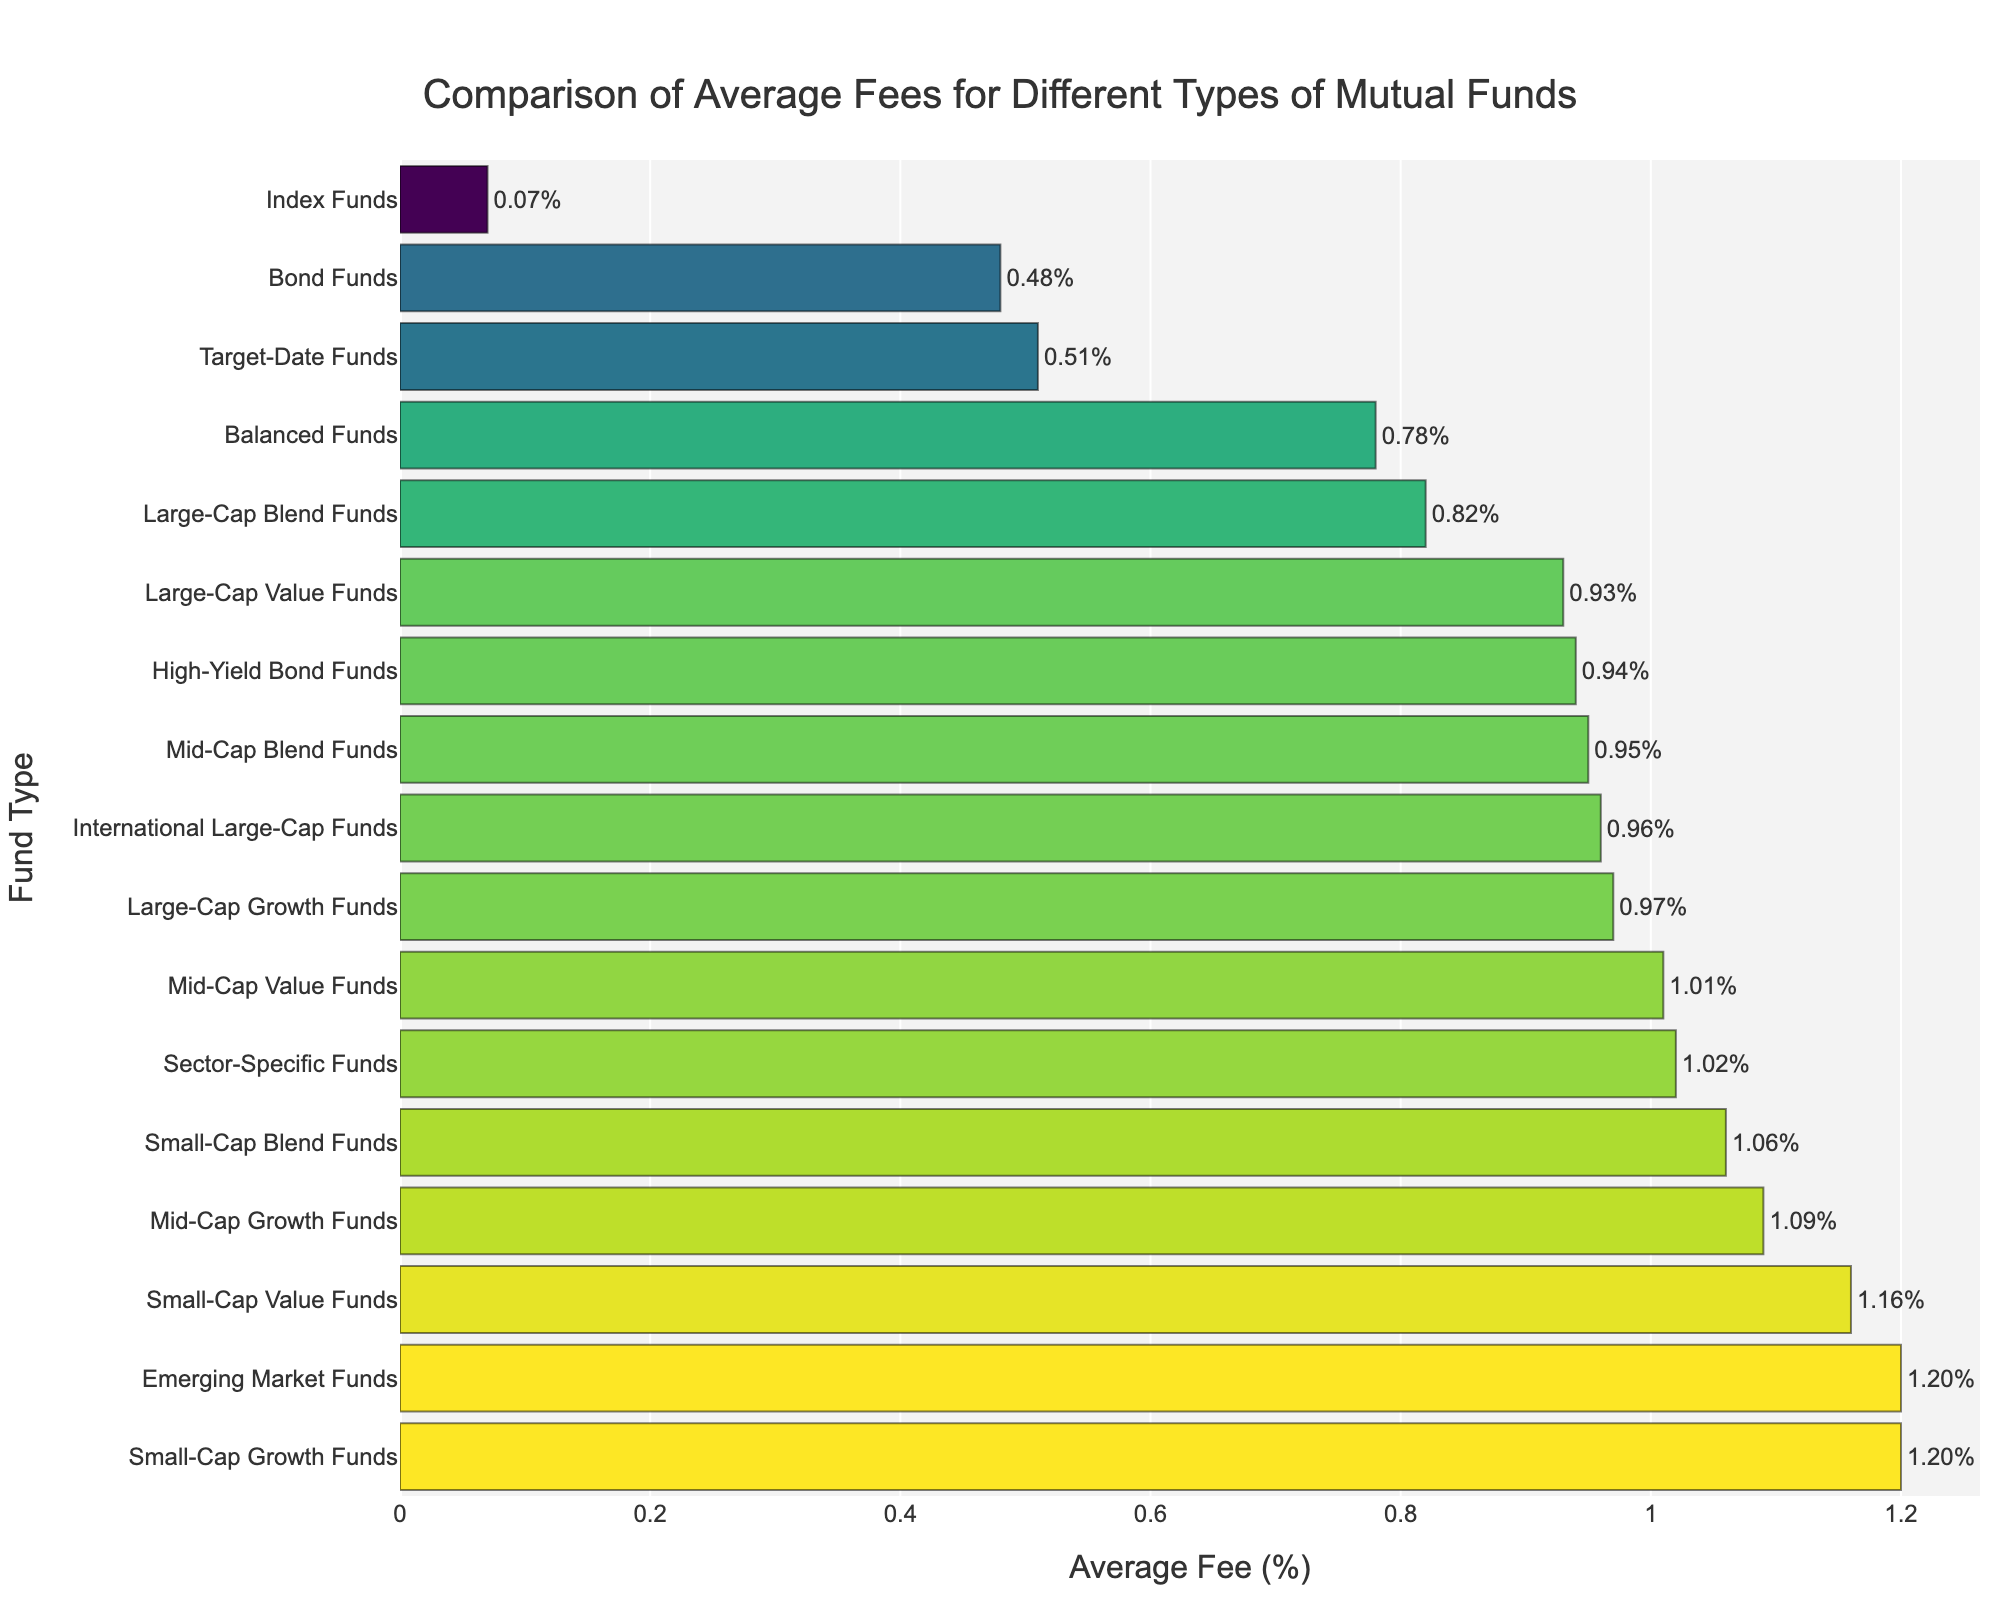What type of mutual fund has the highest average fee? Looking at the bar chart, the highest bar indicates the mutual fund with the highest average fee. The "Small-Cap Growth Funds" has the highest average fee.
Answer: Small-Cap Growth Funds Which has a lower average fee: Bond Funds or High-Yield Bond Funds? By comparing the lengths of the bars for both "Bond Funds" and "High-Yield Bond Funds", we see that the bar for "Bond Funds" is shorter, indicating a lower average fee.
Answer: Bond Funds What is the difference in the average fee between Large-Cap Growth Funds and Index Funds? The average fee for "Large-Cap Growth Funds" is 0.97% and for "Index Funds" is 0.07%. Subtracting these, 0.97 - 0.07 = 0.90.
Answer: 0.90% Are the average fees for Emerging Market Funds and Small-Cap Growth Funds equal? Comparing the bars for "Emerging Market Funds" and "Small-Cap Growth Funds", both bars reach the same value, indicating equal average fees.
Answer: Yes What is the combined average fee percentage of Target-Date Funds and Balanced Funds? The average fee for "Target-Date Funds" is 0.51% and for "Balanced Funds" is 0.78%. Adding these together, 0.51 + 0.78 = 1.29.
Answer: 1.29% Which type of mutual fund has the lowest average fee? The shortest bar indicates the mutual fund with the lowest average fee. The "Index Funds" have the lowest average fee.
Answer: Index Funds How does the average fee of Sector-Specific Funds compare to that of Mid-Cap Growth Funds? The lengths of the bars for "Sector-Specific Funds" and "Mid-Cap Growth Funds" are compared. The bar for "Mid-Cap Growth Funds" is taller, indicating a higher average fee.
Answer: Mid-Cap Growth Funds have a higher fee 